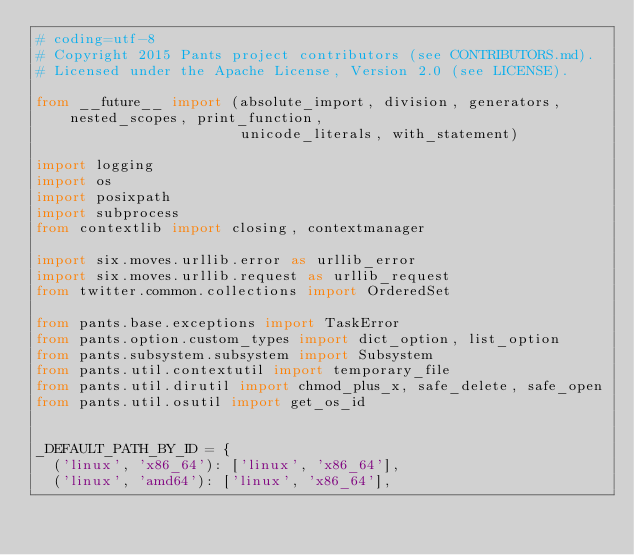<code> <loc_0><loc_0><loc_500><loc_500><_Python_># coding=utf-8
# Copyright 2015 Pants project contributors (see CONTRIBUTORS.md).
# Licensed under the Apache License, Version 2.0 (see LICENSE).

from __future__ import (absolute_import, division, generators, nested_scopes, print_function,
                        unicode_literals, with_statement)

import logging
import os
import posixpath
import subprocess
from contextlib import closing, contextmanager

import six.moves.urllib.error as urllib_error
import six.moves.urllib.request as urllib_request
from twitter.common.collections import OrderedSet

from pants.base.exceptions import TaskError
from pants.option.custom_types import dict_option, list_option
from pants.subsystem.subsystem import Subsystem
from pants.util.contextutil import temporary_file
from pants.util.dirutil import chmod_plus_x, safe_delete, safe_open
from pants.util.osutil import get_os_id


_DEFAULT_PATH_BY_ID = {
  ('linux', 'x86_64'): ['linux', 'x86_64'],
  ('linux', 'amd64'): ['linux', 'x86_64'],</code> 